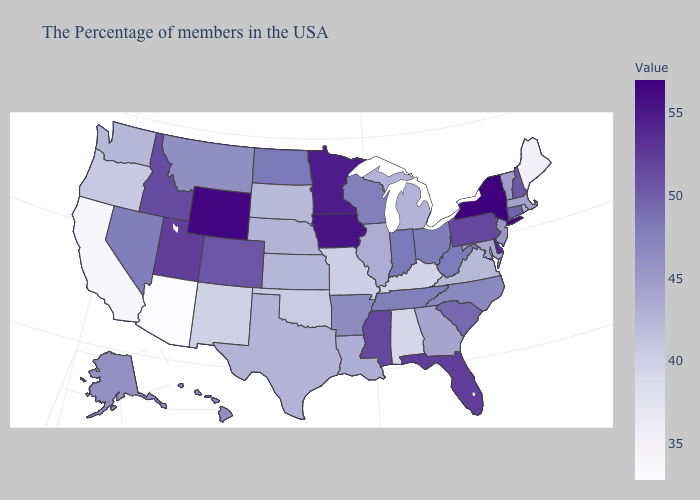Which states have the lowest value in the USA?
Give a very brief answer. Arizona. Among the states that border Oregon , does Idaho have the highest value?
Quick response, please. Yes. Does Virginia have the lowest value in the USA?
Give a very brief answer. No. Which states have the highest value in the USA?
Answer briefly. New York. Which states have the lowest value in the MidWest?
Write a very short answer. Missouri. 